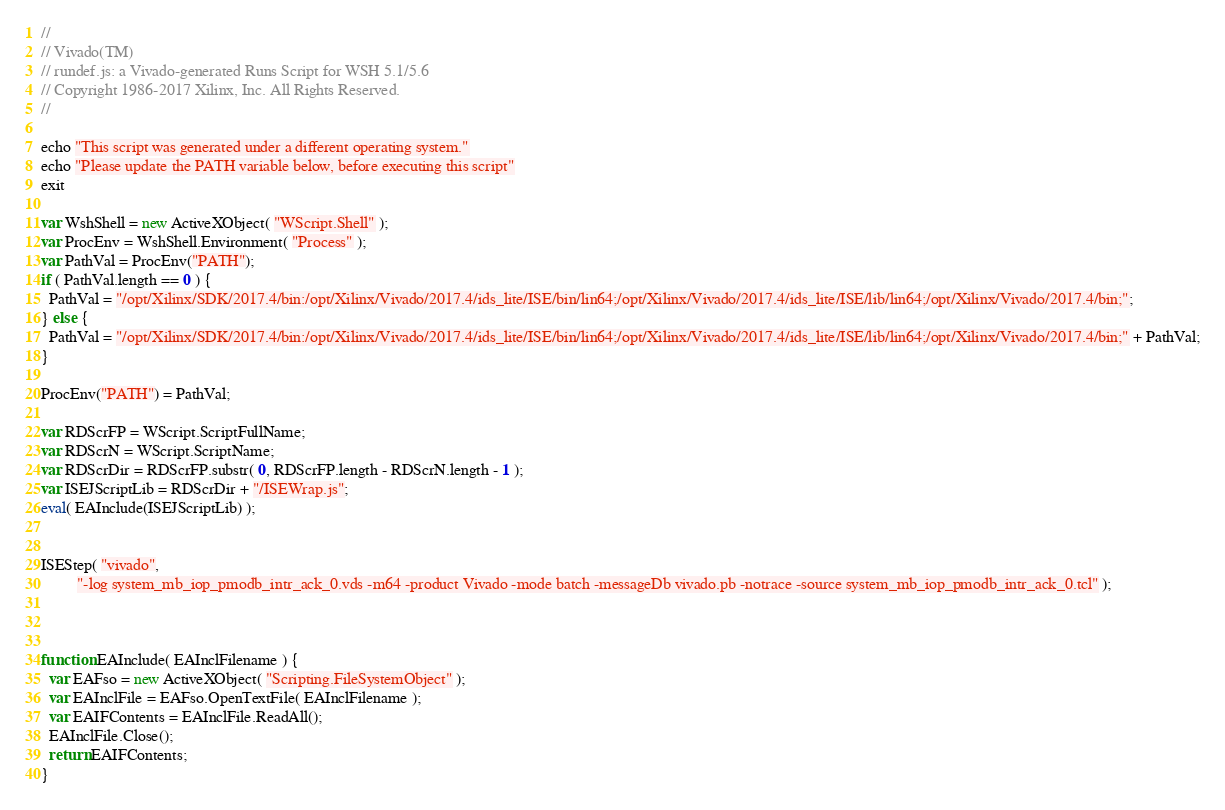<code> <loc_0><loc_0><loc_500><loc_500><_JavaScript_>//
// Vivado(TM)
// rundef.js: a Vivado-generated Runs Script for WSH 5.1/5.6
// Copyright 1986-2017 Xilinx, Inc. All Rights Reserved.
//

echo "This script was generated under a different operating system."
echo "Please update the PATH variable below, before executing this script"
exit

var WshShell = new ActiveXObject( "WScript.Shell" );
var ProcEnv = WshShell.Environment( "Process" );
var PathVal = ProcEnv("PATH");
if ( PathVal.length == 0 ) {
  PathVal = "/opt/Xilinx/SDK/2017.4/bin:/opt/Xilinx/Vivado/2017.4/ids_lite/ISE/bin/lin64;/opt/Xilinx/Vivado/2017.4/ids_lite/ISE/lib/lin64;/opt/Xilinx/Vivado/2017.4/bin;";
} else {
  PathVal = "/opt/Xilinx/SDK/2017.4/bin:/opt/Xilinx/Vivado/2017.4/ids_lite/ISE/bin/lin64;/opt/Xilinx/Vivado/2017.4/ids_lite/ISE/lib/lin64;/opt/Xilinx/Vivado/2017.4/bin;" + PathVal;
}

ProcEnv("PATH") = PathVal;

var RDScrFP = WScript.ScriptFullName;
var RDScrN = WScript.ScriptName;
var RDScrDir = RDScrFP.substr( 0, RDScrFP.length - RDScrN.length - 1 );
var ISEJScriptLib = RDScrDir + "/ISEWrap.js";
eval( EAInclude(ISEJScriptLib) );


ISEStep( "vivado",
         "-log system_mb_iop_pmodb_intr_ack_0.vds -m64 -product Vivado -mode batch -messageDb vivado.pb -notrace -source system_mb_iop_pmodb_intr_ack_0.tcl" );



function EAInclude( EAInclFilename ) {
  var EAFso = new ActiveXObject( "Scripting.FileSystemObject" );
  var EAInclFile = EAFso.OpenTextFile( EAInclFilename );
  var EAIFContents = EAInclFile.ReadAll();
  EAInclFile.Close();
  return EAIFContents;
}
</code> 